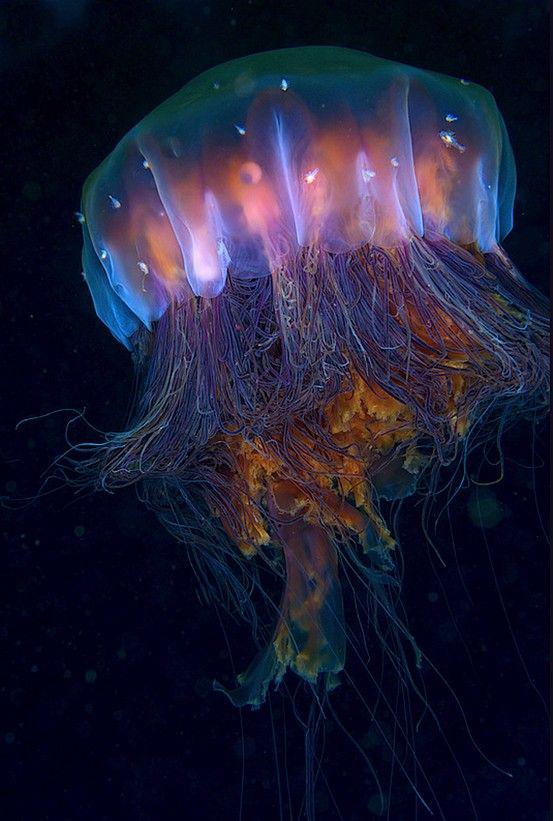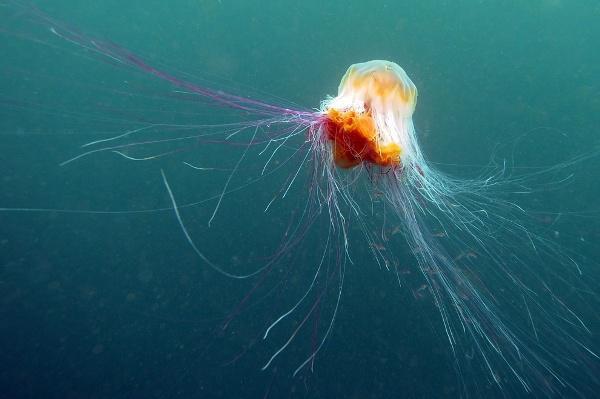The first image is the image on the left, the second image is the image on the right. Evaluate the accuracy of this statement regarding the images: "The left and right image contains the same number of jellyfish.". Is it true? Answer yes or no. Yes. The first image is the image on the left, the second image is the image on the right. For the images shown, is this caption "The left image contains a single jellyfish, which has an upright mushroom-shaped cap that trails stringy and ruffly tentacles beneath it." true? Answer yes or no. Yes. 